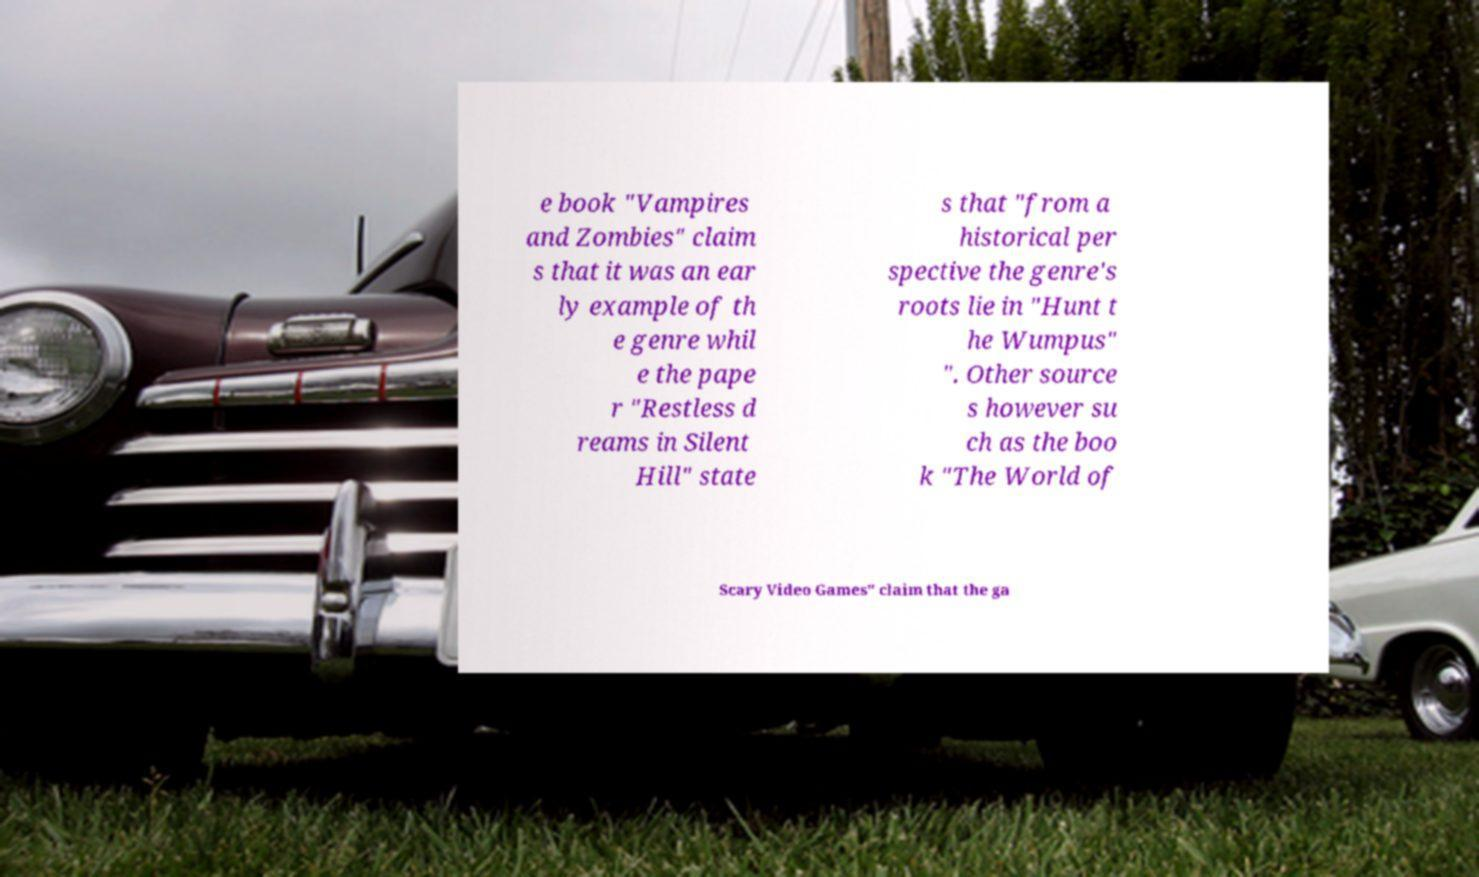Can you read and provide the text displayed in the image?This photo seems to have some interesting text. Can you extract and type it out for me? e book "Vampires and Zombies" claim s that it was an ear ly example of th e genre whil e the pape r "Restless d reams in Silent Hill" state s that "from a historical per spective the genre's roots lie in "Hunt t he Wumpus" ". Other source s however su ch as the boo k "The World of Scary Video Games" claim that the ga 